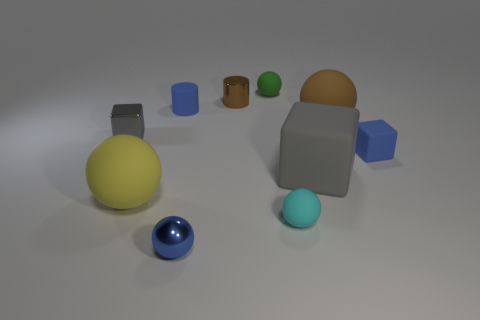Subtract all tiny gray blocks. How many blocks are left? 2 Subtract all cyan cylinders. How many gray cubes are left? 2 Subtract 1 balls. How many balls are left? 4 Subtract all blue cubes. How many cubes are left? 2 Add 3 tiny rubber balls. How many tiny rubber balls exist? 5 Subtract 0 green cylinders. How many objects are left? 10 Subtract all blocks. How many objects are left? 7 Subtract all red spheres. Subtract all yellow cylinders. How many spheres are left? 5 Subtract all blue metallic objects. Subtract all balls. How many objects are left? 4 Add 6 blue cubes. How many blue cubes are left? 7 